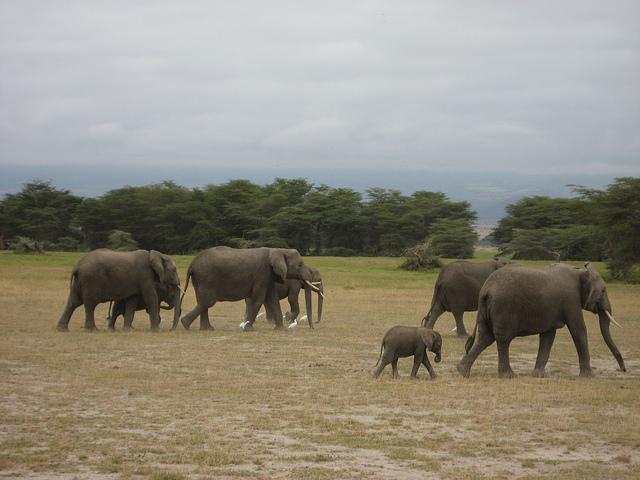How many elephants are in the image?
Give a very brief answer. 7. How many animals are there?
Give a very brief answer. 5. How many elephants are there?
Give a very brief answer. 5. 